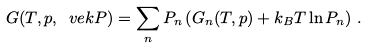<formula> <loc_0><loc_0><loc_500><loc_500>G ( T , p , \ v e k P ) = \sum _ { n } P _ { n } \left ( G _ { n } ( T , p ) + k _ { B } T \ln P _ { n } \right ) \, .</formula> 